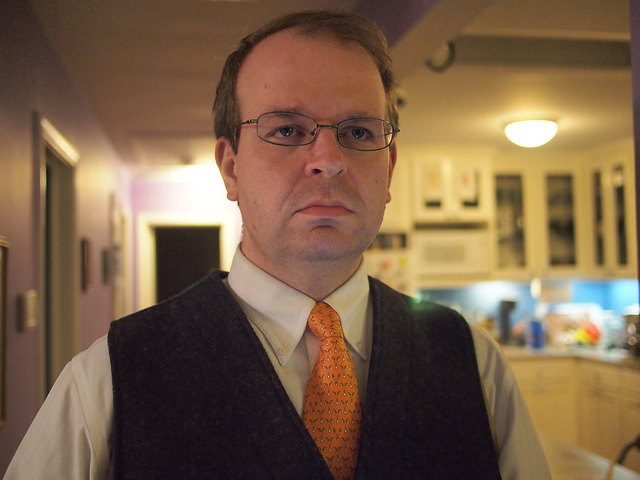<image>Is the man a house Butler? It is ambiguous if the man is a house Butler. Is the man a house Butler? It is uncertain whether the man is a house Butler. 